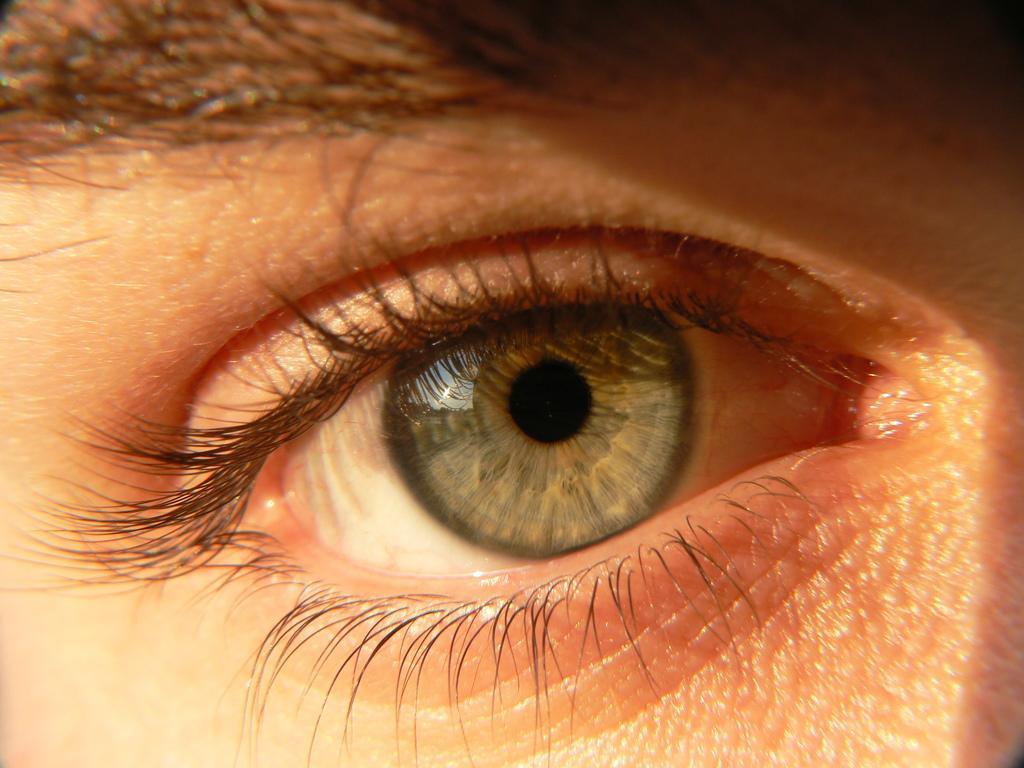Could you give a brief overview of what you see in this image? In the foreground of this image, there is an eye of a person, where we can see pupil, iris and sclera. We can also see, eyelids and the eyebrow. 